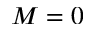Convert formula to latex. <formula><loc_0><loc_0><loc_500><loc_500>M = 0</formula> 